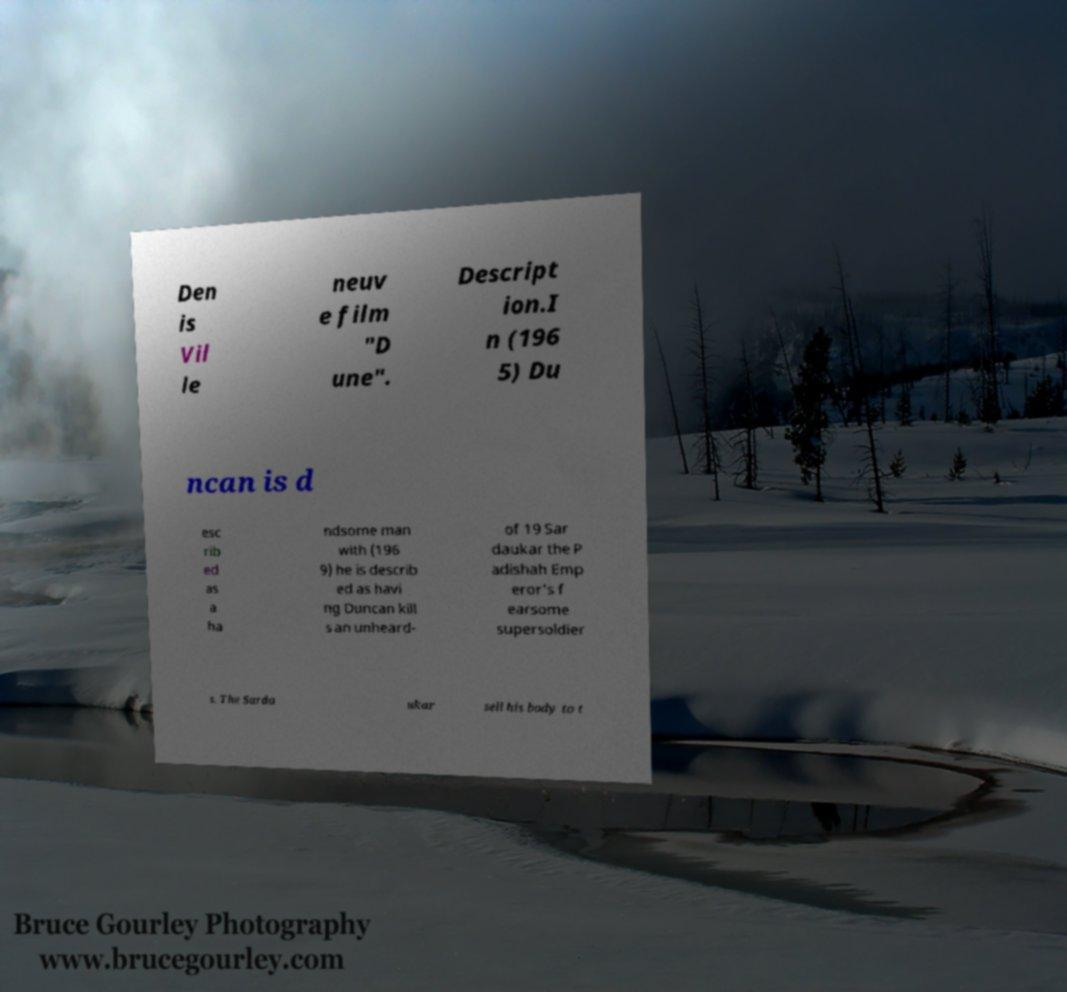Please identify and transcribe the text found in this image. Den is Vil le neuv e film "D une". Descript ion.I n (196 5) Du ncan is d esc rib ed as a ha ndsome man with (196 9) he is describ ed as havi ng Duncan kill s an unheard- of 19 Sar daukar the P adishah Emp eror's f earsome supersoldier s. The Sarda ukar sell his body to t 